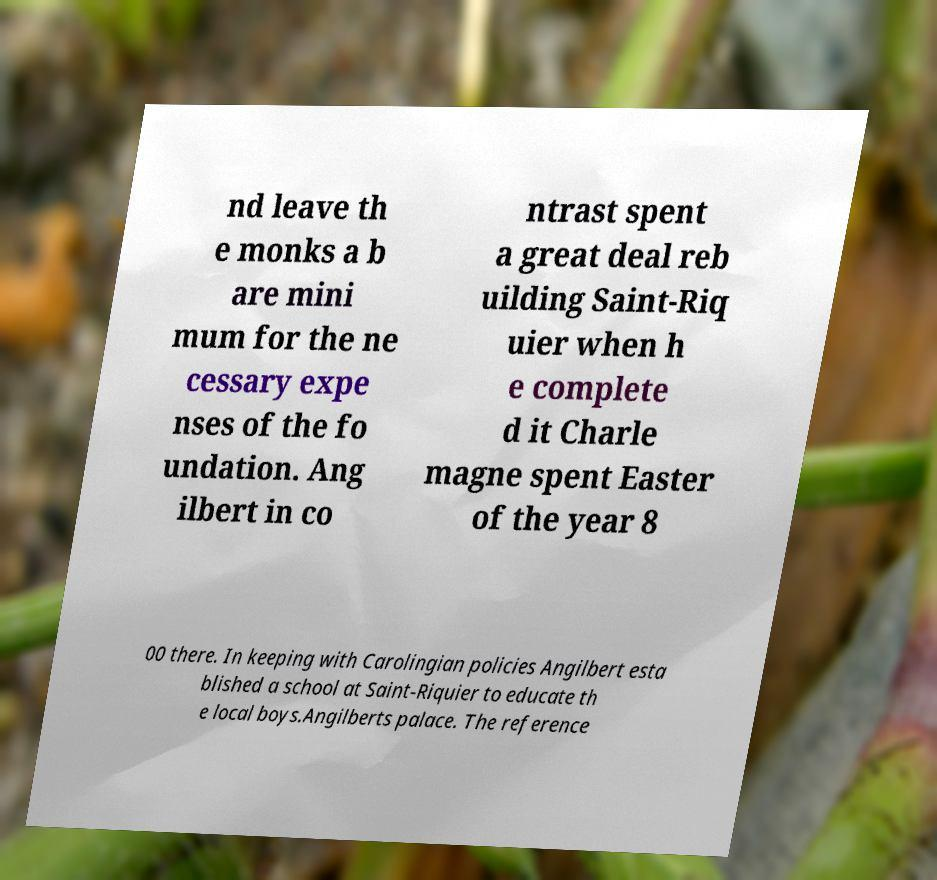Can you read and provide the text displayed in the image?This photo seems to have some interesting text. Can you extract and type it out for me? nd leave th e monks a b are mini mum for the ne cessary expe nses of the fo undation. Ang ilbert in co ntrast spent a great deal reb uilding Saint-Riq uier when h e complete d it Charle magne spent Easter of the year 8 00 there. In keeping with Carolingian policies Angilbert esta blished a school at Saint-Riquier to educate th e local boys.Angilberts palace. The reference 